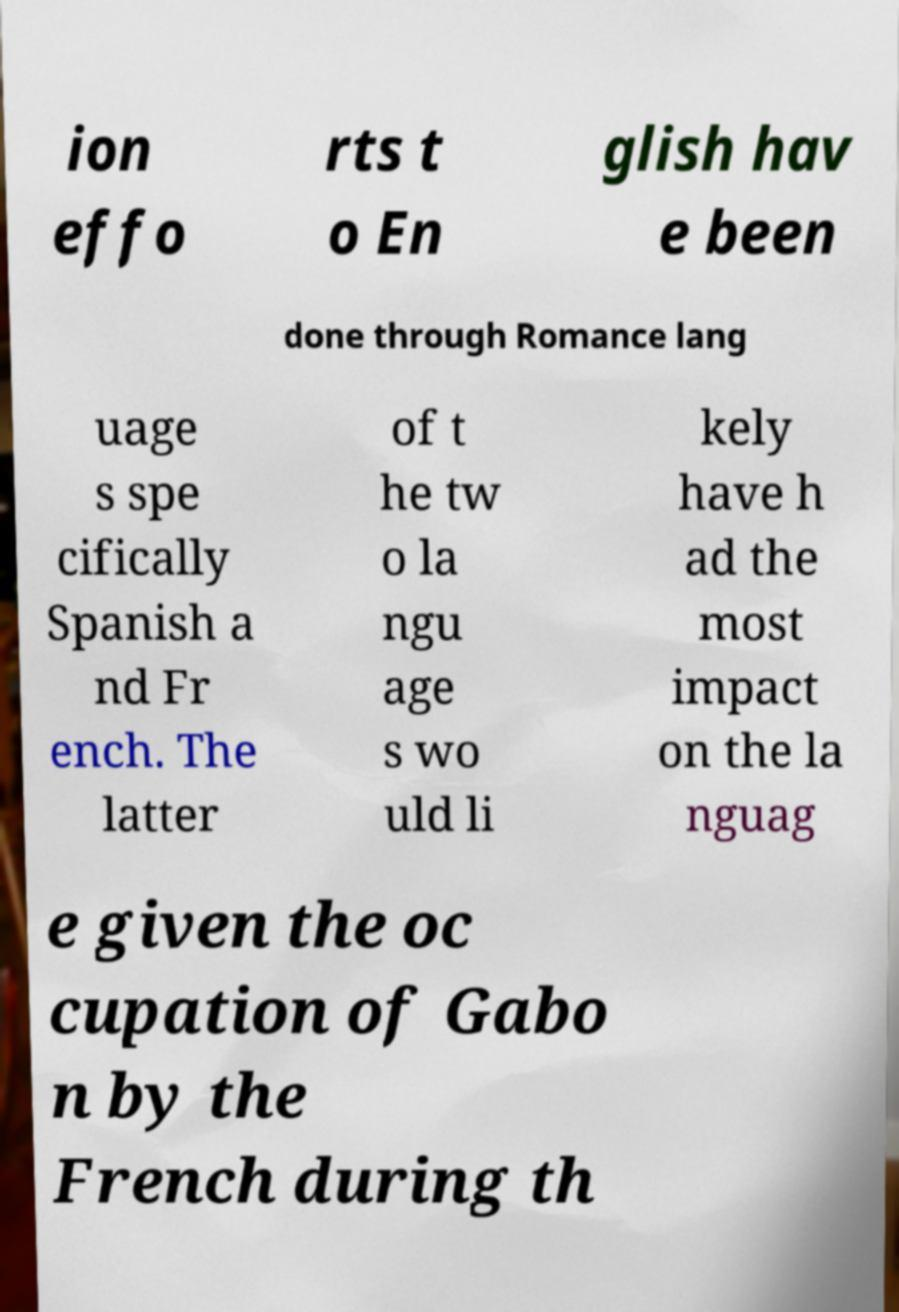Could you extract and type out the text from this image? ion effo rts t o En glish hav e been done through Romance lang uage s spe cifically Spanish a nd Fr ench. The latter of t he tw o la ngu age s wo uld li kely have h ad the most impact on the la nguag e given the oc cupation of Gabo n by the French during th 